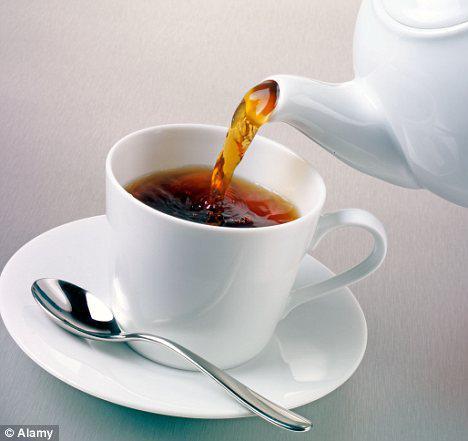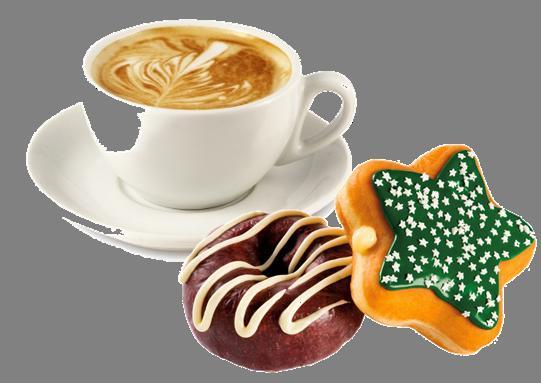The first image is the image on the left, the second image is the image on the right. Analyze the images presented: Is the assertion "In one image, a liquid is being poured into a white cup from a white tea kettle" valid? Answer yes or no. Yes. The first image is the image on the left, the second image is the image on the right. For the images displayed, is the sentence "A white teapot is pouring tea into a cup in one of the images." factually correct? Answer yes or no. Yes. 